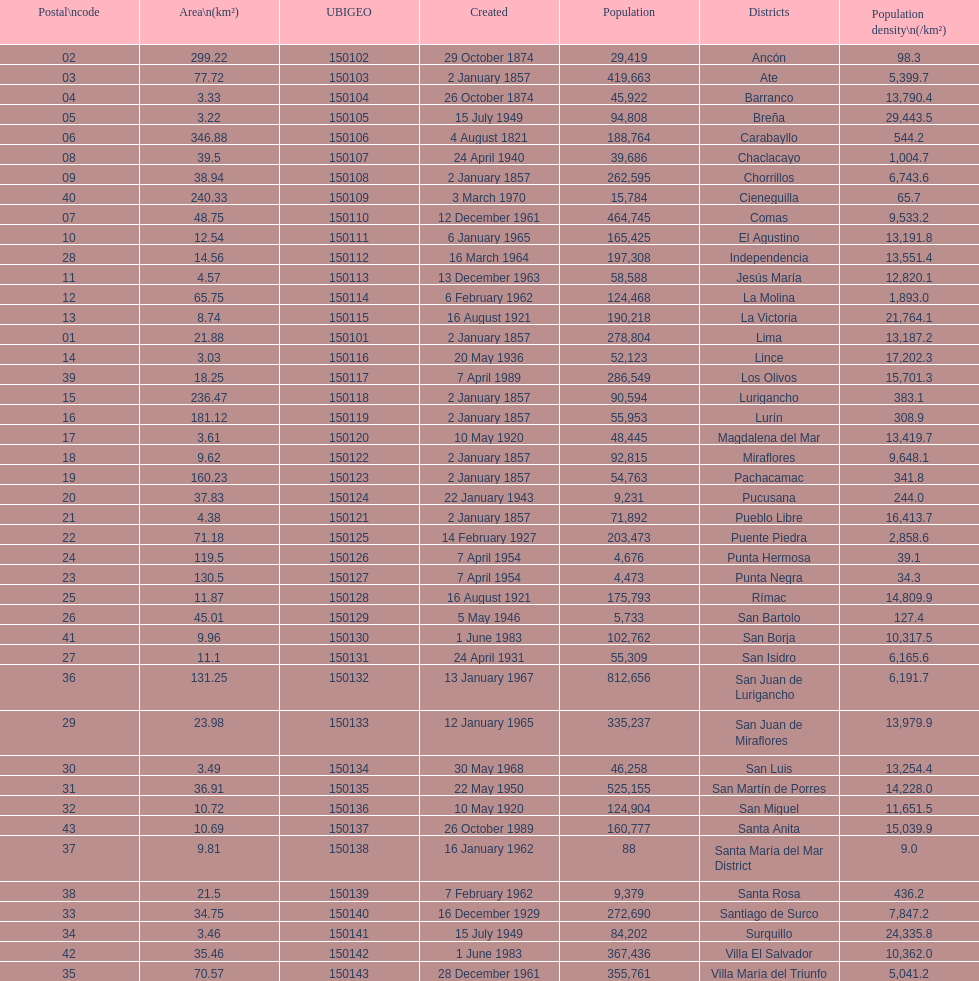What is the total number of districts created in the 1900's? 32. 